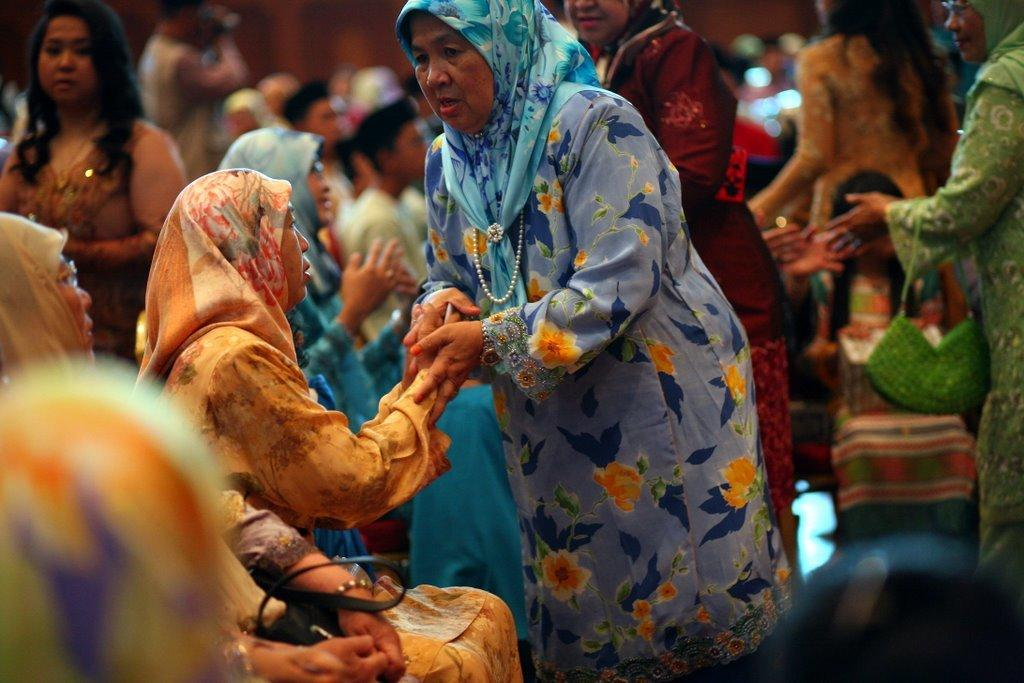What is the main subject of the image? The main subject of the image is a group of people. How are the people dressed in the image? The people are wearing different color dresses in the image. What are the people doing in the image? Some people are sitting, while others are standing in the image. What type of humor can be seen in the image? There is no humor present in the image; it features a group of people wearing different color dresses and some sitting while others are standing. 